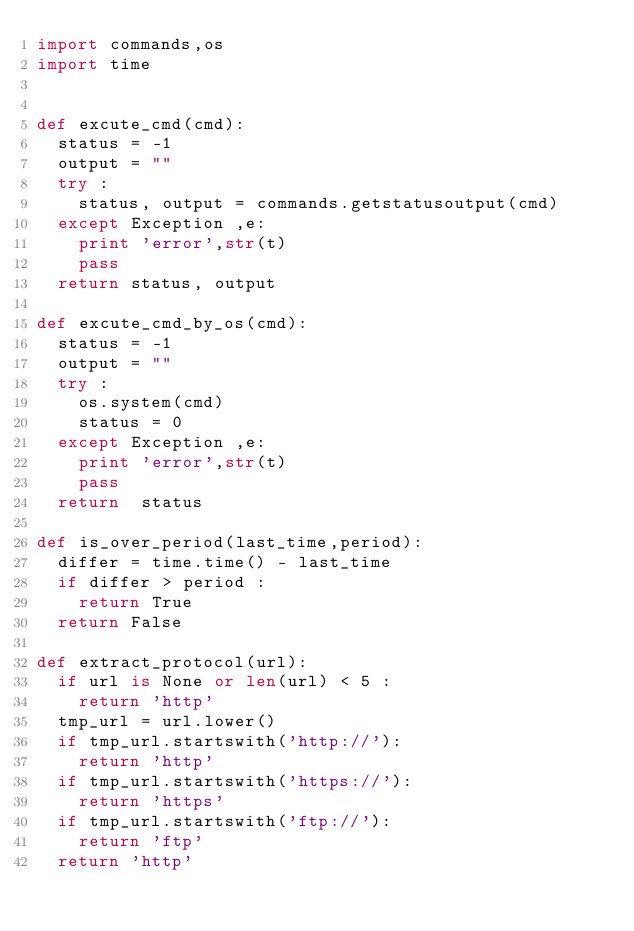<code> <loc_0><loc_0><loc_500><loc_500><_Python_>import commands,os
import time


def excute_cmd(cmd):
	status = -1 
	output = ""
	try :
		status, output = commands.getstatusoutput(cmd)
	except Exception ,e:
		print 'error',str(t)
		pass
	return status, output

def excute_cmd_by_os(cmd):
	status = -1 
	output = ""
	try :
		os.system(cmd)
		status = 0
	except Exception ,e:
		print 'error',str(t)
		pass
	return  status

def is_over_period(last_time,period):
	differ = time.time() - last_time
	if differ > period :
		return True
	return False

def extract_protocol(url):
	if url is None or len(url) < 5 :
		return 'http'
	tmp_url = url.lower()
	if tmp_url.startswith('http://'):
		return 'http'
	if tmp_url.startswith('https://'):
		return 'https'
	if tmp_url.startswith('ftp://'):
		return 'ftp'
	return 'http'

</code> 